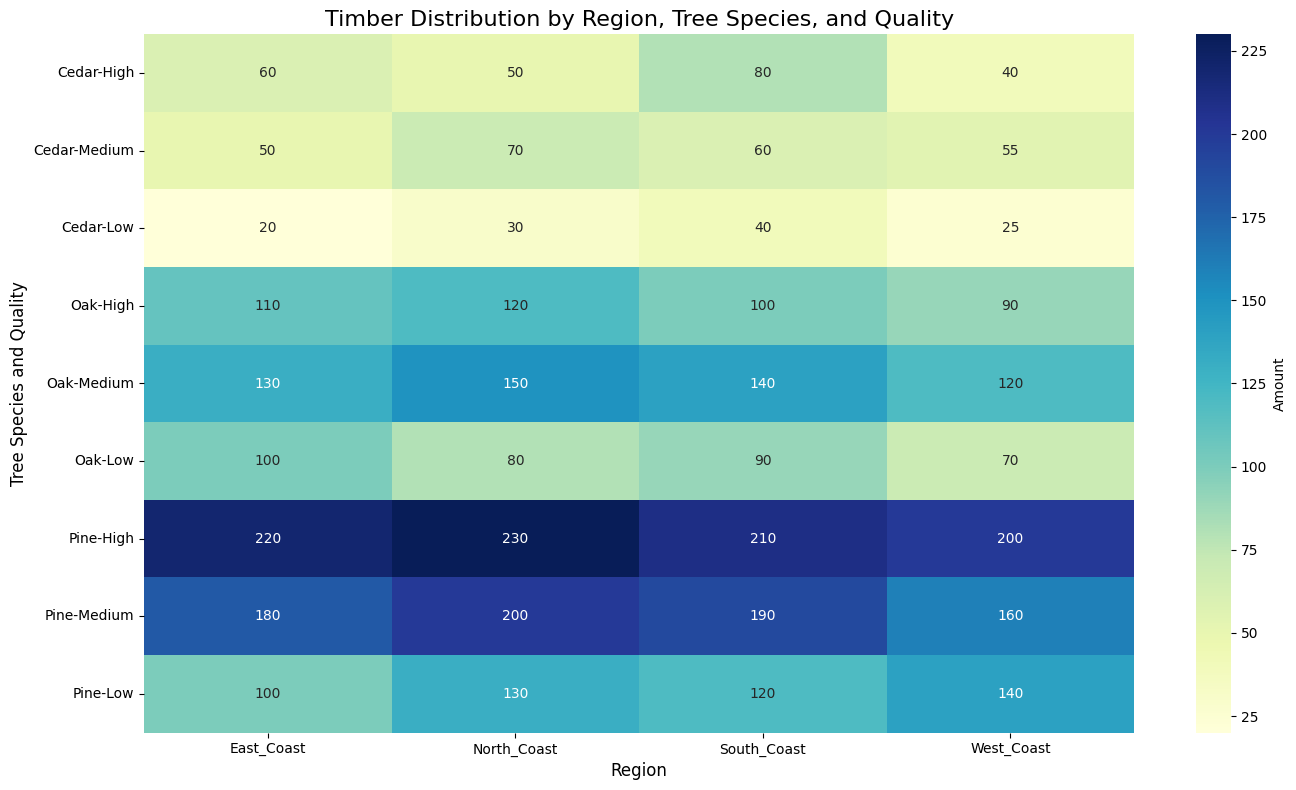What's the region with the highest amount of High-Quality Oak timber? From the heatmap, locate the row corresponding to "Oak" and the column for "High" quality. Then, find the region with the highest number in that row.
Answer: North Coast Which tree species has the least total timber amount in the West Coast? Sum the amounts for all qualities for each tree species in the West Coast column. Compare the totals for Oak, Pine, and Cedar to determine the species with the smallest sum.
Answer: Cedar Compare the total amount of Medium-Quality Pine timber across all regions. Which region has the highest amount? Locate the "Pine" row and the "Medium" quality from the heatmap. Sum the values across the regions for "Medium" quality within the Pine row and identify the region with the highest amount.
Answer: North Coast Which quality grade has the smallest amount of Cedar timber in the East Coast? For the "East Coast" column, locate the different quality levels under the "Cedar" row. Identify the quality level with the smallest number.
Answer: Low What is the total amount of High-Quality timber for all tree species across all regions? Locate the rows corresponding to "High" quality for all tree species in each region's column. Sum all these values to get the total.
Answer: 1160 Is Medium-Quality Oak timber amount greater in North Coast or South Coast? Compare the values of Medium-Quality Oak timber between the "North Coast" and "South Coast" columns from the heatmap.
Answer: North Coast Which tree species and quality combination has the highest amount of timber in the South Coast? Within the South Coast column, identify the cell with the highest number. Then, determine the corresponding tree species and quality.
Answer: Pine, High Calculate the difference between the total amounts of Pine and Cedar timber in all regions combined. Sum the amounts of Pine and Cedar timber across all qualities and regions. Subtract the total amount of Cedar from the total amount of Pine.
Answer: 1760 What is the predominant color in the heatmap for Low-Quality Oak timber, and what does it signify in terms of amount? Check the color scale for Low-Quality Oak timber values, which are represented by a shade of the color used. Determine what range the color represents based on the color bar legend.
Answer: A lighter shade of blue, signifying low amounts For High-Quality Cedar timber, which region has the least amount, and what is that amount? Locate the row for "Cedar" and the "High" quality, then identify the region with the smallest value in that row.
Answer: West Coast, 40 